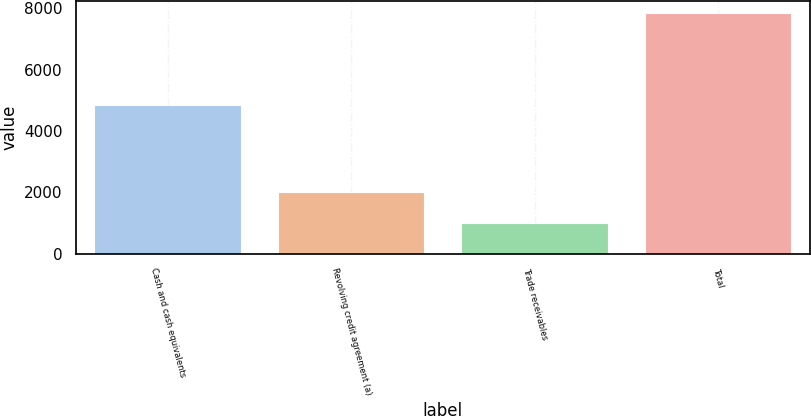Convert chart to OTSL. <chart><loc_0><loc_0><loc_500><loc_500><bar_chart><fcel>Cash and cash equivalents<fcel>Revolving credit agreement (a)<fcel>Trade receivables<fcel>Total<nl><fcel>4860<fcel>2000<fcel>1000<fcel>7860<nl></chart> 